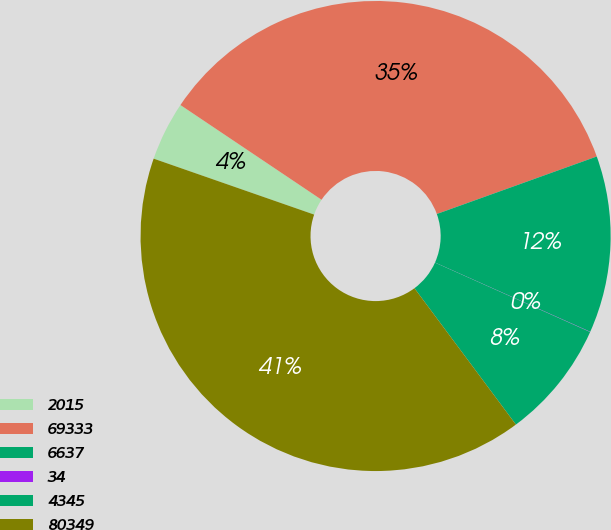Convert chart to OTSL. <chart><loc_0><loc_0><loc_500><loc_500><pie_chart><fcel>2015<fcel>69333<fcel>6637<fcel>34<fcel>4345<fcel>80349<nl><fcel>4.07%<fcel>35.1%<fcel>12.17%<fcel>0.02%<fcel>8.12%<fcel>40.52%<nl></chart> 